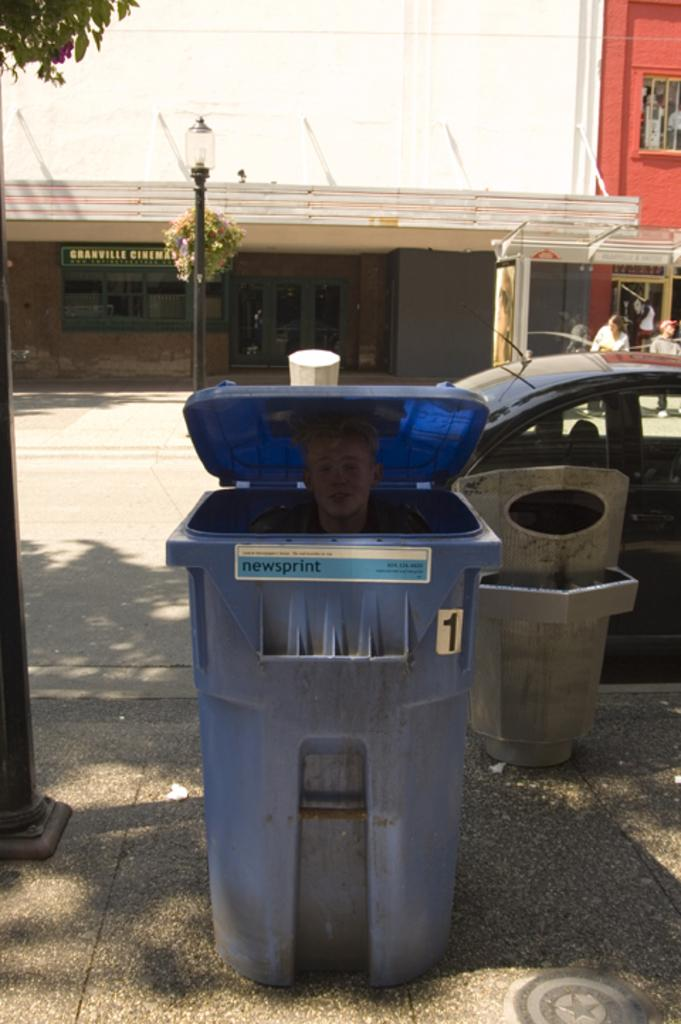<image>
Offer a succinct explanation of the picture presented. Person peeking out of a blue garbage can that says "newsprint" on it. 